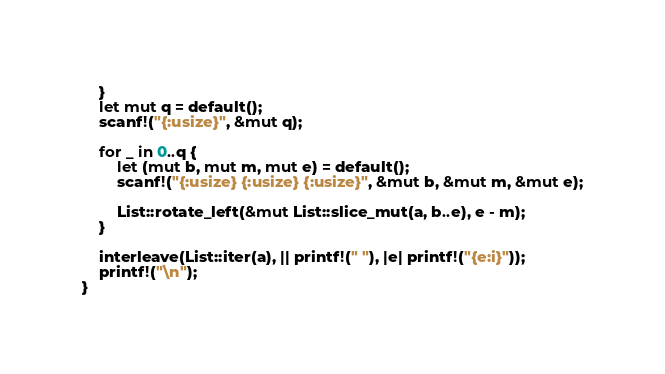Convert code to text. <code><loc_0><loc_0><loc_500><loc_500><_Rust_>    }
    let mut q = default();
    scanf!("{:usize}", &mut q);

    for _ in 0..q {
        let (mut b, mut m, mut e) = default();
        scanf!("{:usize} {:usize} {:usize}", &mut b, &mut m, &mut e);

        List::rotate_left(&mut List::slice_mut(a, b..e), e - m);
    }

    interleave(List::iter(a), || printf!(" "), |e| printf!("{e:i}"));
    printf!("\n");
}
</code> 